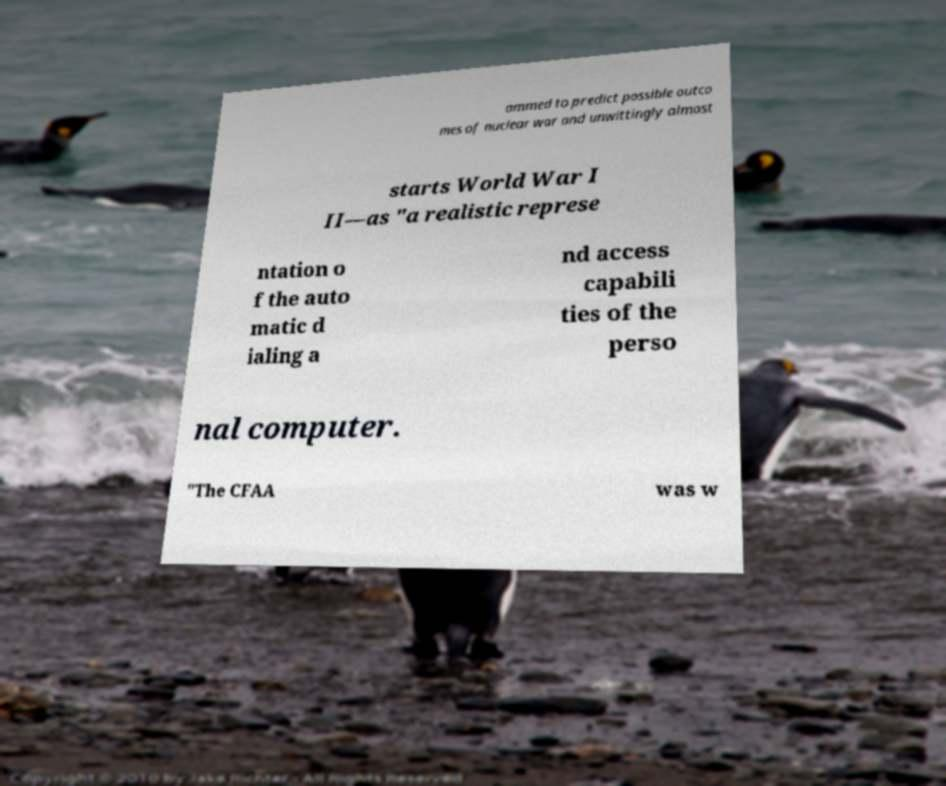What messages or text are displayed in this image? I need them in a readable, typed format. ammed to predict possible outco mes of nuclear war and unwittingly almost starts World War I II—as "a realistic represe ntation o f the auto matic d ialing a nd access capabili ties of the perso nal computer. "The CFAA was w 